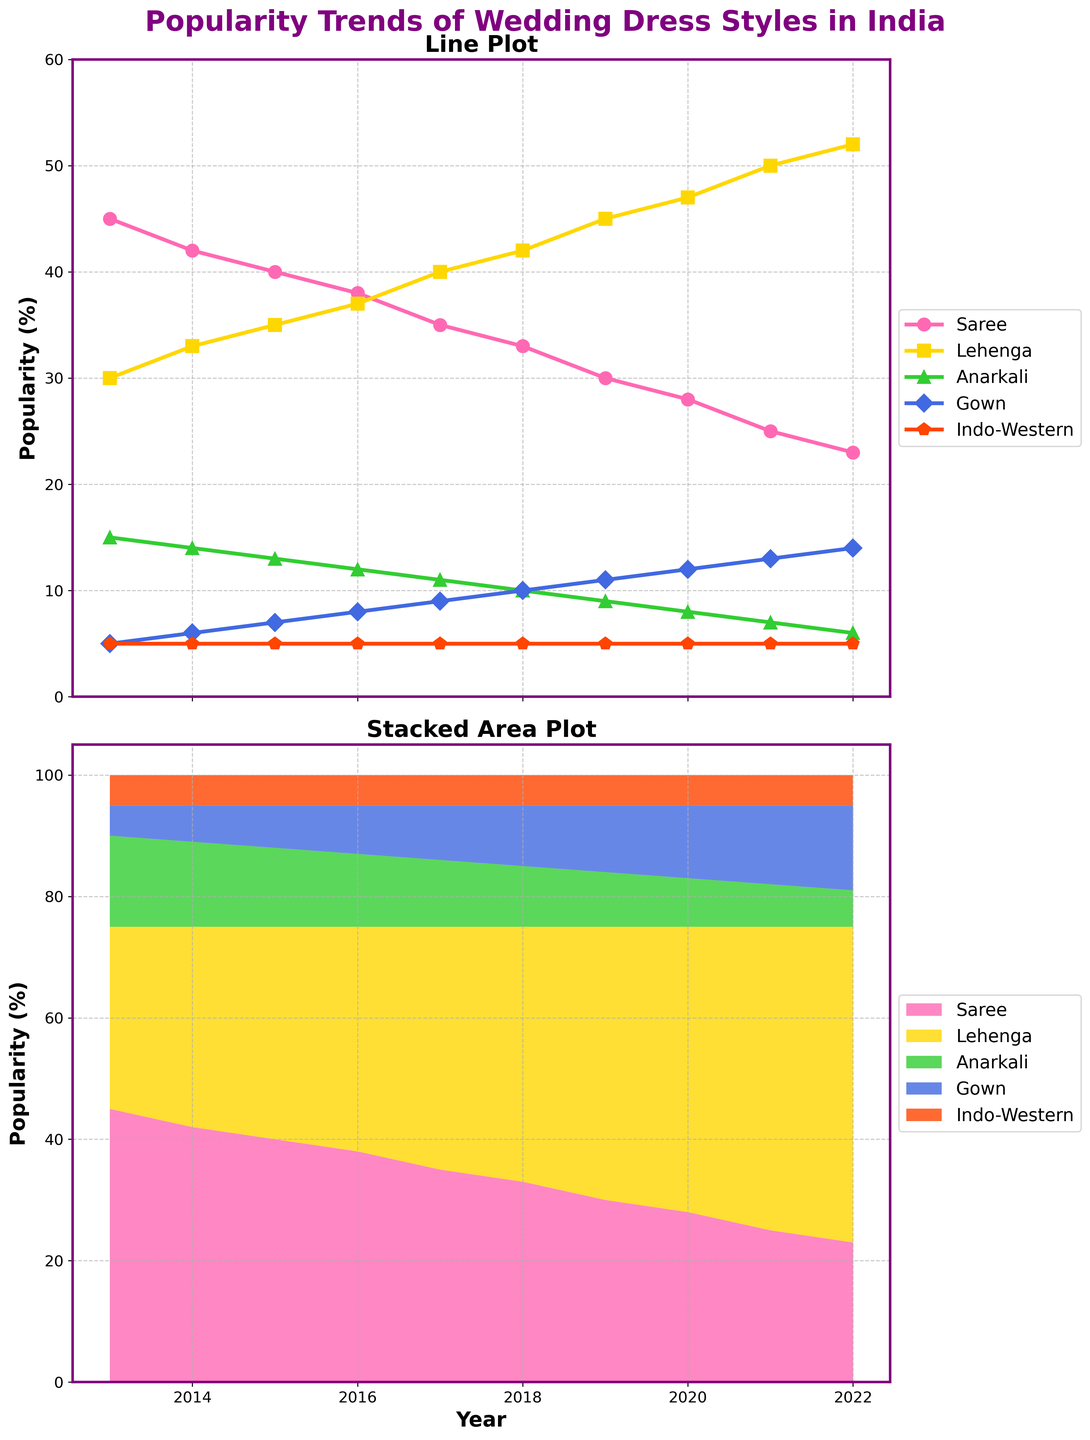What's the overall trend for the popularity of Saree from 2013 to 2022? The plot shows a steady decline in the popularity of the Saree over the years. Starting at 45% in 2013 and decreasing gradually to 23% by 2022.
Answer: Decreasing When did Lehenga surpass Saree in popularity? By observing the lines for Lehenga and Saree, Lehenga surpasses Saree between 2016 and 2017.
Answer: 2017 Which wedding dress style maintained a stable popularity trend throughout the decade? The popularity of Indo-Western wedding dresses remained stable at 5% throughout the decade according to the line plot.
Answer: Indo-Western How did the popularity of Gown change between 2015 and 2020? The line plot for Gown shows that its popularity increased from 7% in 2015 to 12% in 2020.
Answer: Increased What was the combined popularity of Anarkali and Gown in 2022? The plot shows that the popularity of Anarkali is 6% and Gown is 14% in 2022. Adding these two values gives a combined popularity of 6% + 14% = 20%.
Answer: 20% Which dress style had the highest popularity in 2021? The line plot indicates that Lehenga had the highest popularity in 2021, reaching 50%.
Answer: Lehenga Which year saw the highest popularity for Lehenga? The highest point on the line plot for Lehenga is in 2022 with a popularity of 52%.
Answer: 2022 By how much did the popularity of Anarkali decrease between 2013 and 2022? The plot shows the popularity of Anarkali was 15% in 2013 and decreased to 6% in 2022. The drop is 15% - 6% = 9%.
Answer: 9% Which styles of wedding dresses showed an increasing trend over the years? Both Lehenga and Gown show an increasing trend from 2013 to 2022 based on the line plot.
Answer: Lehenga and Gown How does the combined popularity of all styles in 2015 compare to 2020 in the stacked area plot? For 2015, adding the values: Saree (40%), Lehenga (35%), Anarkali (13%), Gown (7%), Indo-Western (5%) results in 40+35+13+7+5=100%. For 2020, adding the values: Saree (28%), Lehenga (47%), Anarkali (8%), Gown (12%), Indo-Western (5%) results in 28+47+8+12+5=100%. Thus, the combined popularity remains the same at 100% for both years.
Answer: Same 